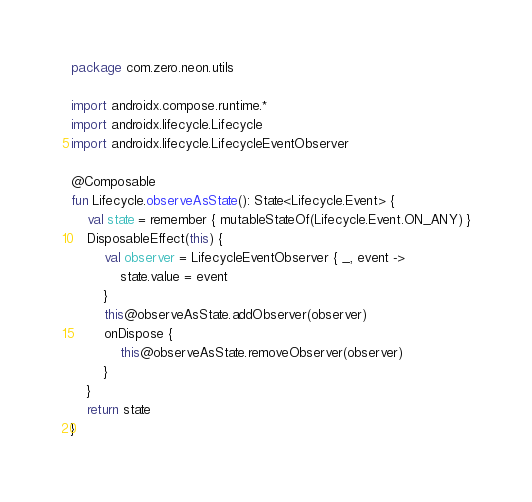<code> <loc_0><loc_0><loc_500><loc_500><_Kotlin_>package com.zero.neon.utils

import androidx.compose.runtime.*
import androidx.lifecycle.Lifecycle
import androidx.lifecycle.LifecycleEventObserver

@Composable
fun Lifecycle.observeAsState(): State<Lifecycle.Event> {
    val state = remember { mutableStateOf(Lifecycle.Event.ON_ANY) }
    DisposableEffect(this) {
        val observer = LifecycleEventObserver { _, event ->
            state.value = event
        }
        this@observeAsState.addObserver(observer)
        onDispose {
            this@observeAsState.removeObserver(observer)
        }
    }
    return state
}</code> 